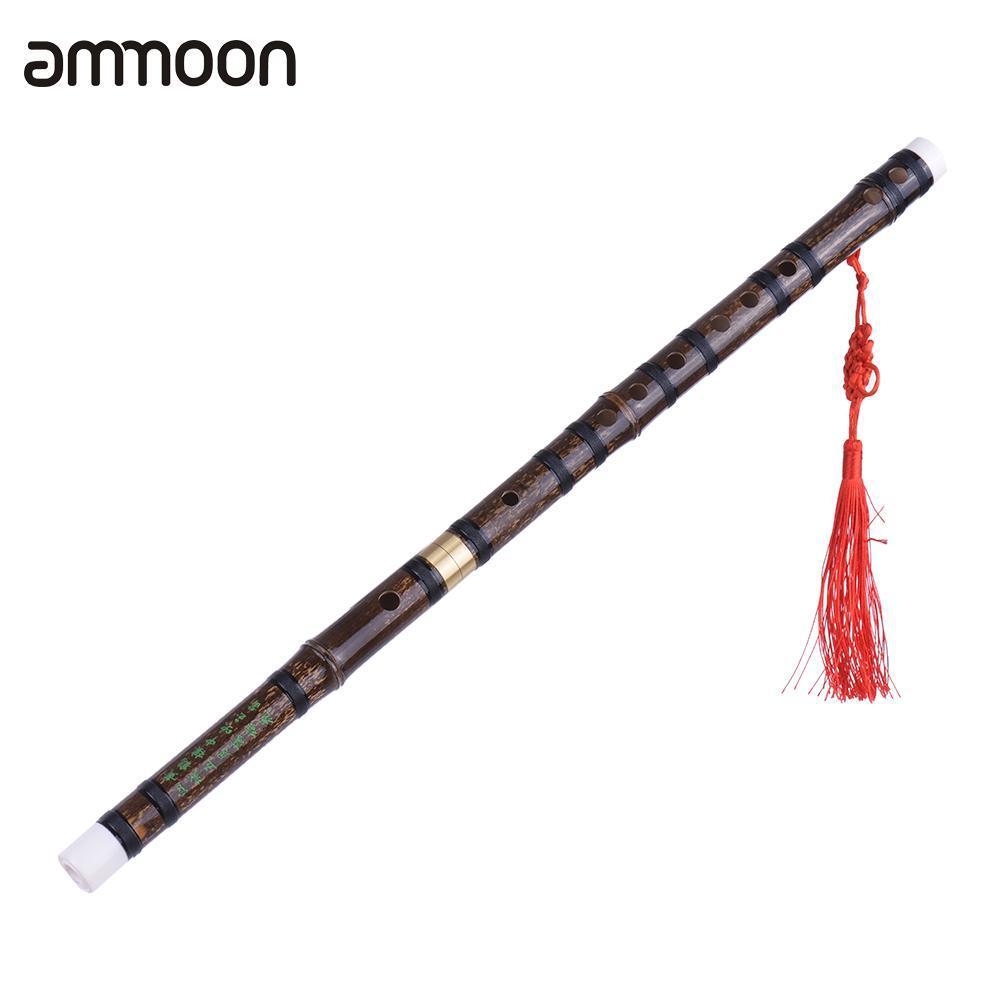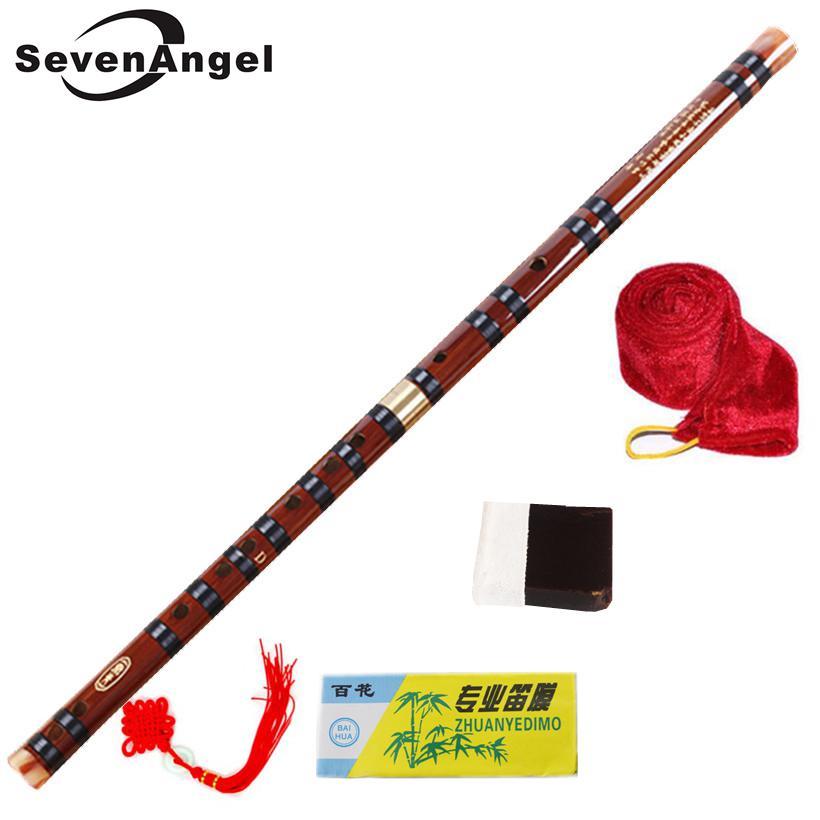The first image is the image on the left, the second image is the image on the right. Examine the images to the left and right. Is the description "The left and right image contains the same number of flutes with red tassels." accurate? Answer yes or no. Yes. 